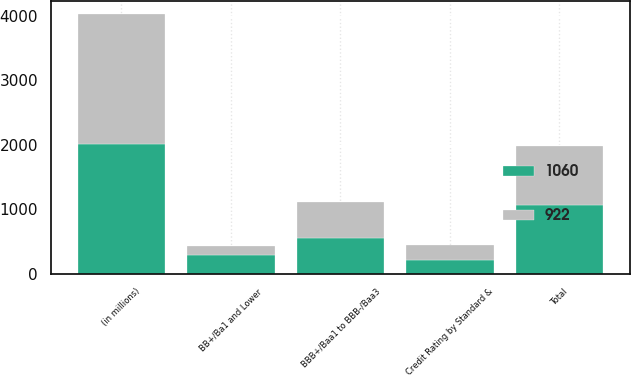Convert chart to OTSL. <chart><loc_0><loc_0><loc_500><loc_500><stacked_bar_chart><ecel><fcel>(in millions)<fcel>Credit Rating by Standard &<fcel>BBB+/Baa1 to BBB-/Baa3<fcel>BB+/Ba1 and Lower<fcel>Total<nl><fcel>922<fcel>2017<fcel>220<fcel>550<fcel>152<fcel>922<nl><fcel>1060<fcel>2016<fcel>218<fcel>559<fcel>283<fcel>1060<nl></chart> 